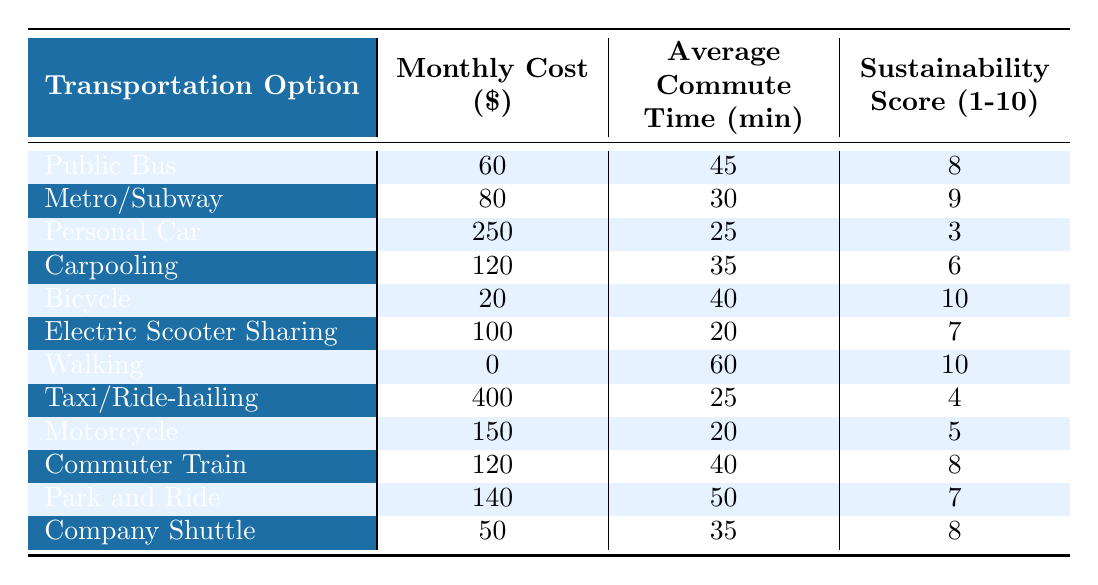What is the monthly cost of using a bicycle? The table lists the monthly cost for a bicycle as $20.
Answer: 20 Which transportation option has the highest sustainability score? The bicycle has the highest sustainability score of 10, as indicated in the table.
Answer: Bicycle What is the average commute time for using the metro/subway? The table states that the average commute time for the metro/subway is 30 minutes.
Answer: 30 How much more does it cost to use a personal car compared to walking? A personal car costs $250, while walking costs $0. The difference is 250 - 0 = 250.
Answer: 250 Which option is the cheapest mode of transportation? The table shows that walking costs $0, making it the cheapest option.
Answer: Walking What is the total monthly cost if a commuter uses both the metro/subway and carpooling? The cost of the metro/subway is $80 and carpooling is $120. Total cost is 80 + 120 = 200.
Answer: 200 Is the average commute time longer for the park and ride compared to the personal car? Park and ride has an average commute time of 50 minutes, while the personal car has 25 minutes, confirming that park and ride is longer.
Answer: Yes What is the sustainability score for electric scooter sharing? The electric scooter sharing has a sustainability score of 7, as shown in the table.
Answer: 7 How does the monthly cost of taxi/ride-hailing compare to riding a bus? Taxi/ride-hailing costs $400, while the public bus costs $60. The difference is 400 - 60 = 340, making taxi/ride-hailing much more expensive.
Answer: 340 If a commuter uses both the train and carpooling, what will their total monthly cost be? The commuter train costs $120 and carpooling costs $120. Total cost is 120 + 120 = 240.
Answer: 240 Which two transportation options have similar average commute times of around 40 minutes? The public bus (45 min) and the commuter train (40 min) have comparable times, while carpooling (35 min) is slightly less.
Answer: Public Bus and Commuter Train How many transportation options have a sustainability score of 8 or higher? The options with scores of 8 or higher are the public bus, metro/subway, bicycle, commuter train, and company shuttle, totaling 5 options.
Answer: 5 